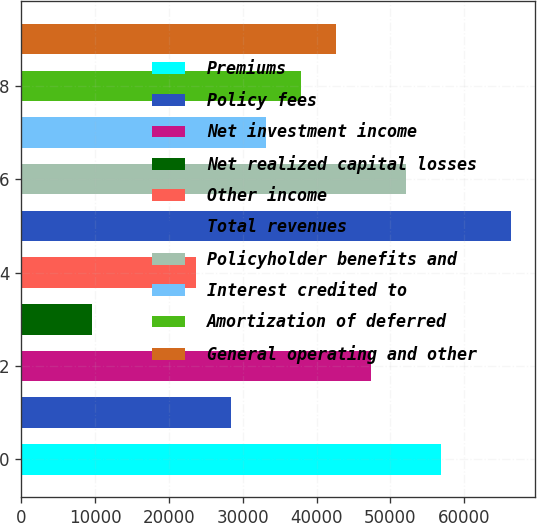Convert chart. <chart><loc_0><loc_0><loc_500><loc_500><bar_chart><fcel>Premiums<fcel>Policy fees<fcel>Net investment income<fcel>Net realized capital losses<fcel>Other income<fcel>Total revenues<fcel>Policyholder benefits and<fcel>Interest credited to<fcel>Amortization of deferred<fcel>General operating and other<nl><fcel>56859.2<fcel>28448.6<fcel>47389<fcel>9508.2<fcel>23713.5<fcel>66329.4<fcel>52124.1<fcel>33183.7<fcel>37918.8<fcel>42653.9<nl></chart> 